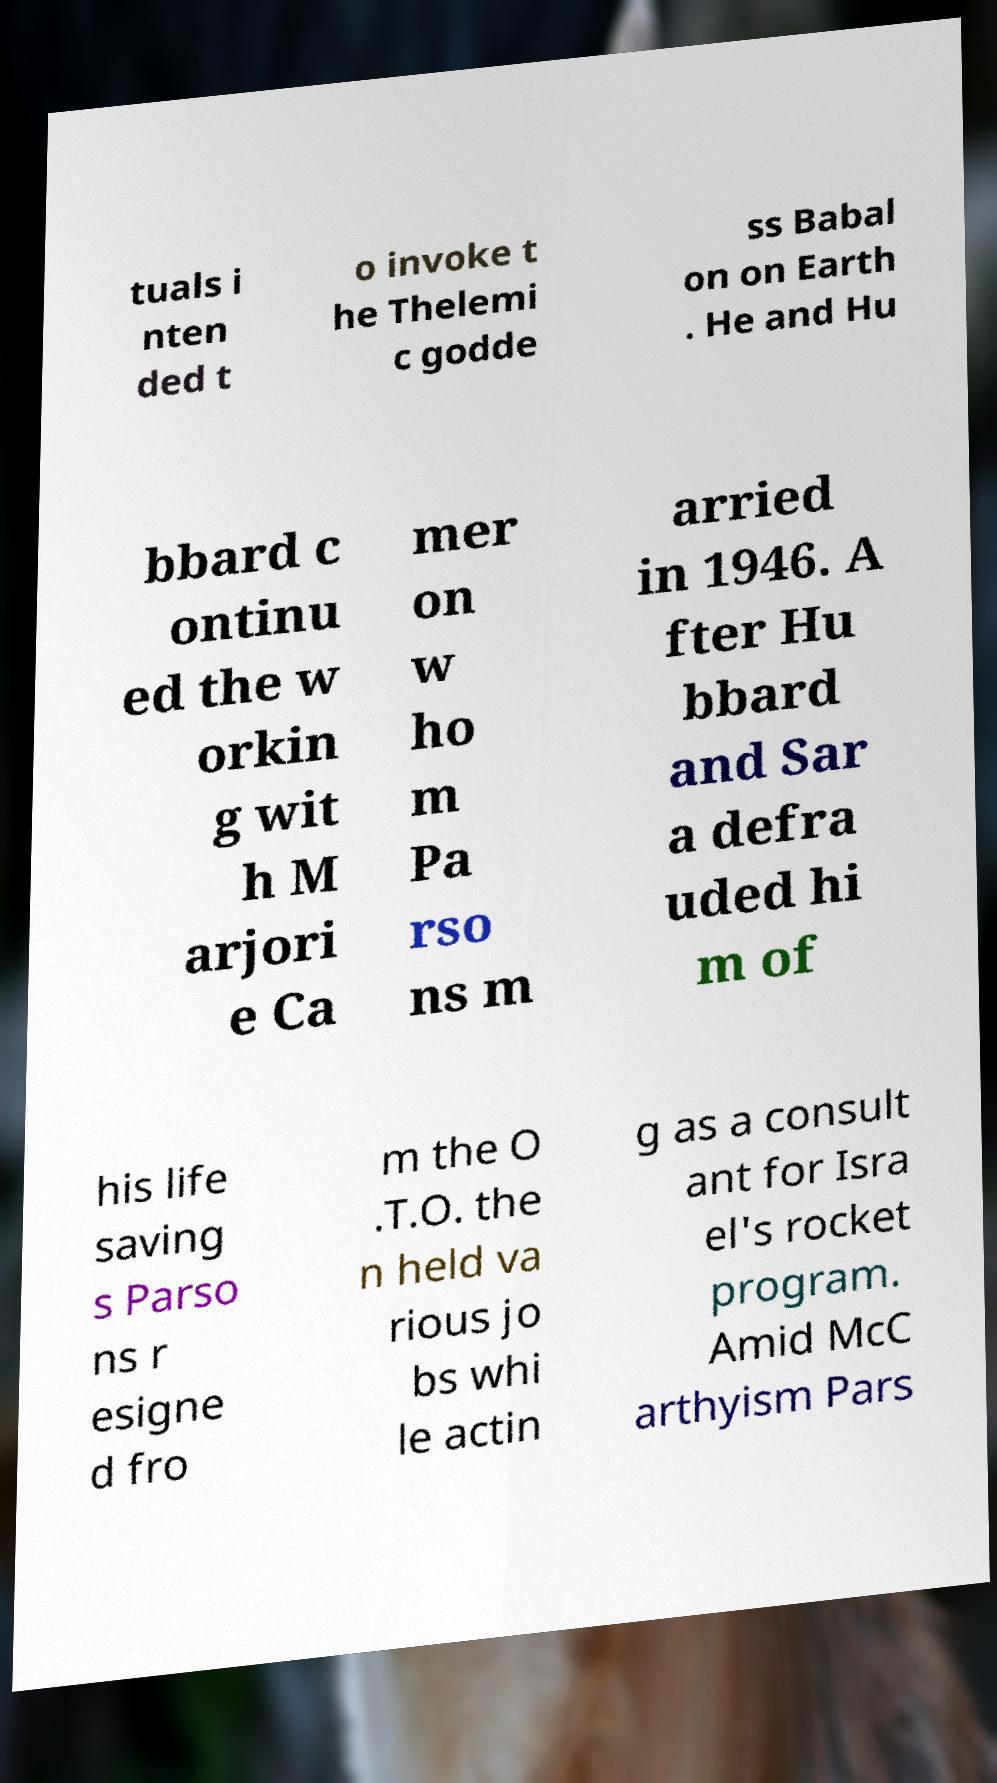Could you assist in decoding the text presented in this image and type it out clearly? tuals i nten ded t o invoke t he Thelemi c godde ss Babal on on Earth . He and Hu bbard c ontinu ed the w orkin g wit h M arjori e Ca mer on w ho m Pa rso ns m arried in 1946. A fter Hu bbard and Sar a defra uded hi m of his life saving s Parso ns r esigne d fro m the O .T.O. the n held va rious jo bs whi le actin g as a consult ant for Isra el's rocket program. Amid McC arthyism Pars 